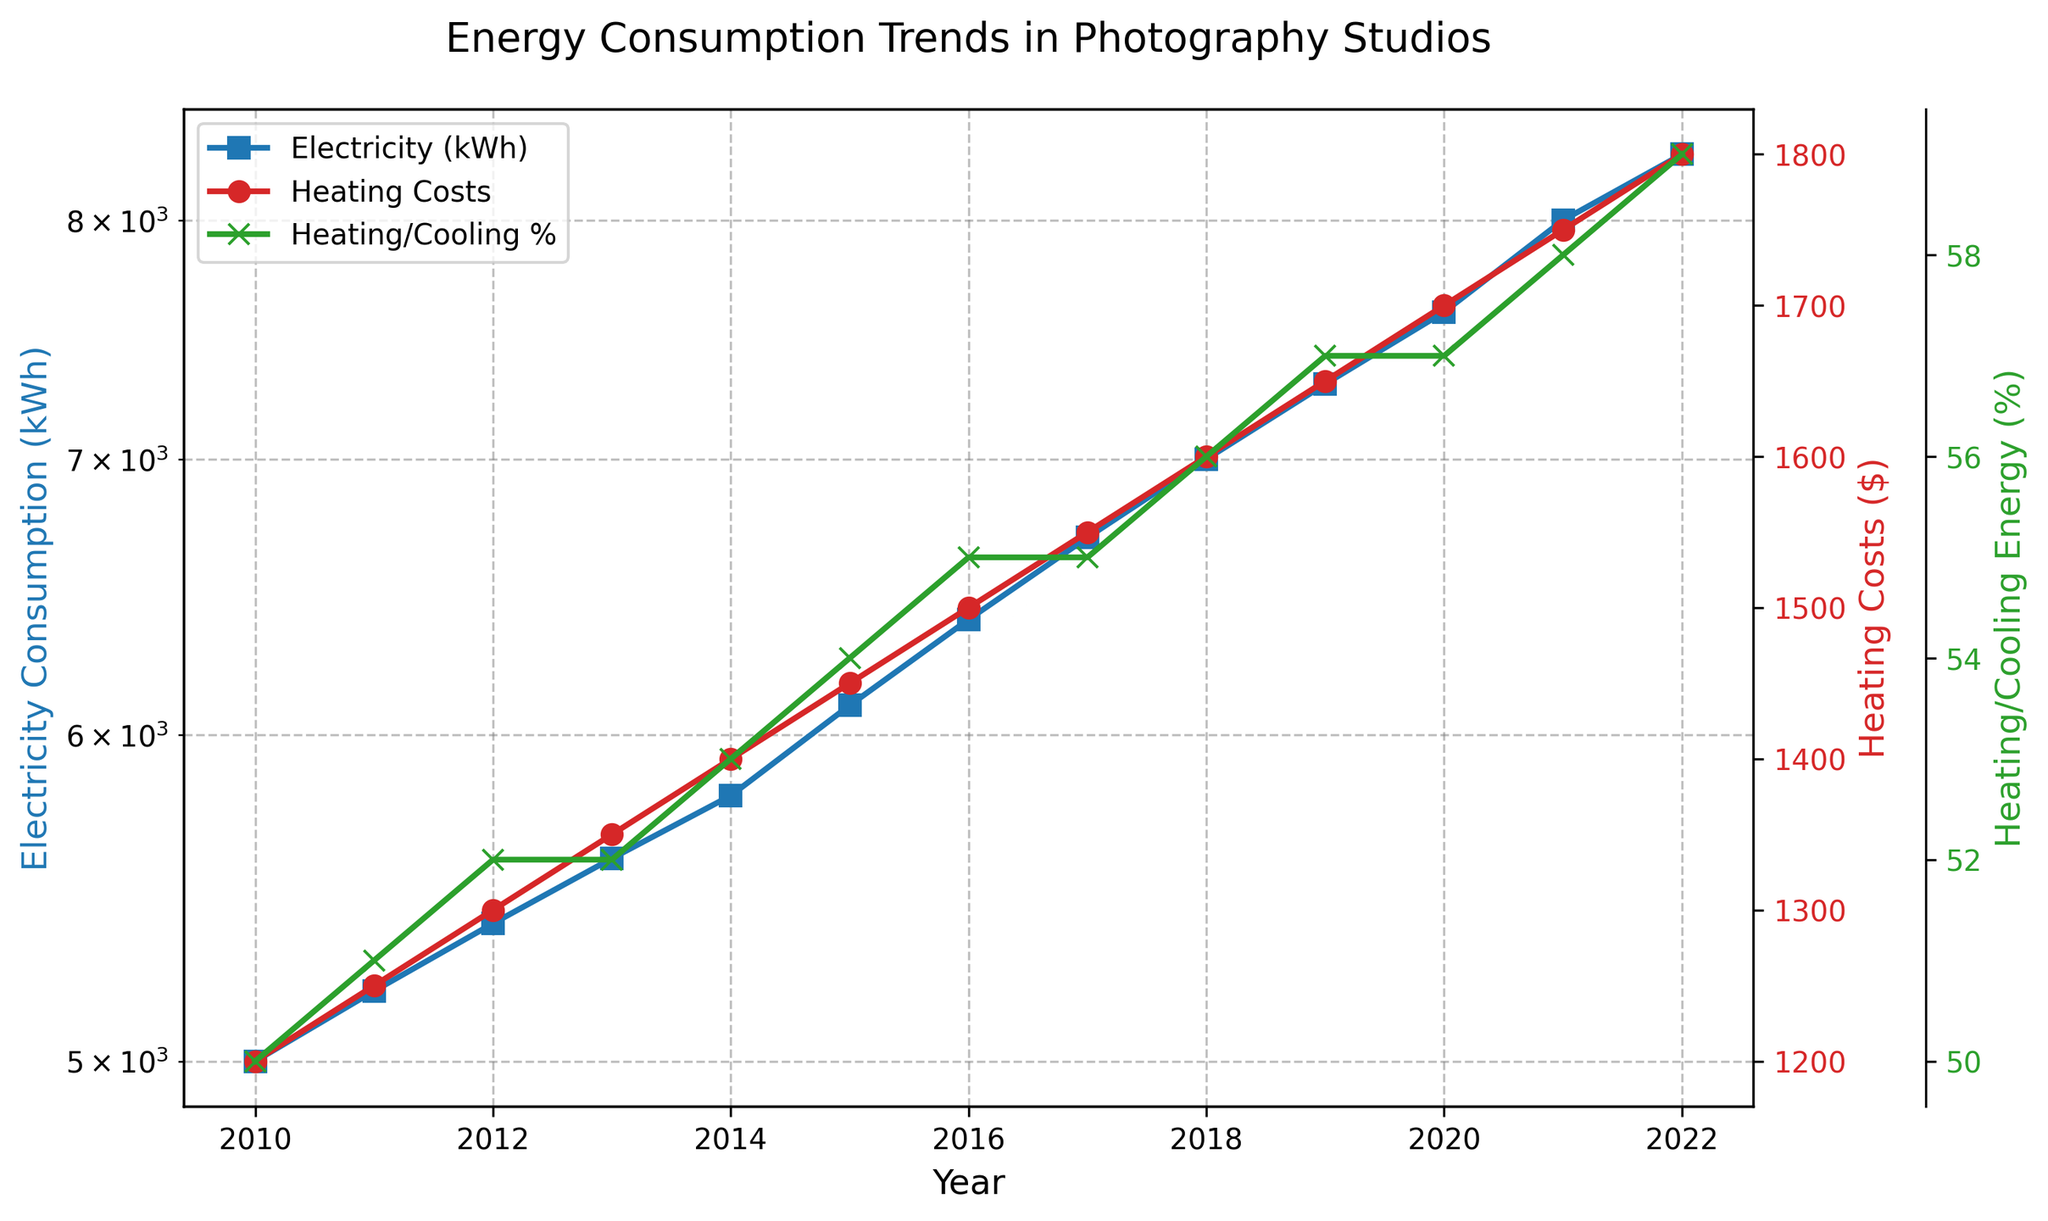What year did the Electricity Consumption reach 8,000 kWh? The Electricity Consumption data series marked with blue circles shows when the consumption reached 8,000 kWh. By tracing from the 8,000 kWh point to the year, we see that it occurred in the year 2021.
Answer: 2021 By what percentage did Heating Costs increase from 2010 to 2022? The Heating Costs in 2010 were $1200 and increased to $1800 in 2022. The percentage increase is calculated by the formula: ((1800 - 1200) / 1200) * 100. This results in ((600) / 1200) * 100 = 50%.
Answer: 50% Which component reached the highest value in 2021: Electricity Consumption, Heating Costs, or Heating/Cooling Percentage? In 2021, Electricity Consumption was 8,000 kWh, Heating Costs were $1750, and Heating/Cooling Percentage was 58%. The highest value among these in numerical terms is the Electricity Consumption at 8,000 kWh.
Answer: Electricity Consumption In which year did the Heating/Cooling Percentage jump by the largest value from the previous year? By looking at the green line representing the Heating/Cooling Percentage, the largest year-on-year jump is between 2021, at 58%, and 2022, at 59%, which is an increase of 1%. This is the largest visible increment between any consecutive years.
Answer: 2022 Compare the Heating Costs trend with the Electricity Consumption trend visually. What observation can you make about their growth patterns over the years? Visually, both the red line (Heating Costs) and the blue line (Electricity Consumption) show steady upward trends. However, Heating Costs appear to increase more smoothly every year, while the Electricity Consumption rises more rapidly, particularly visible in the latter part of the timeline (post-2015).
Answer: Both trends consistently increase, but Electricity Consumption grows more rapidly For the year 2015, if Heating Costs make up 54% of the total energy spending, what would be the other energy spending amount? If Heating Costs are $1450 and they constitute 54% of total energy spending, the total energy spending is 1450/0.54 ≈ $2685. Other energy spending would then be 2685 - 1450 = $1235.
Answer: $1235 Did the Heating/Cooling Percentage ever decrease or stagnate from one year to the next? By tracing the green line, we observe that the Heating/Cooling Percentage either increases or stays the same every year. There is no year where it shows a decrease, but there is stagnation in 2013 and 2017, where the percentage remained the same as the previous year.
Answer: Stagnates in 2013 and 2017 When were Heating Costs $1500 and what was the corresponding Electricity Consumption in that year? By checking the red line for Heating Costs, $1500 happened in 2016. The Electricity Consumption for this year, mapped from the blue line, was 6400 kWh.
Answer: 2016, 6400 kWh 